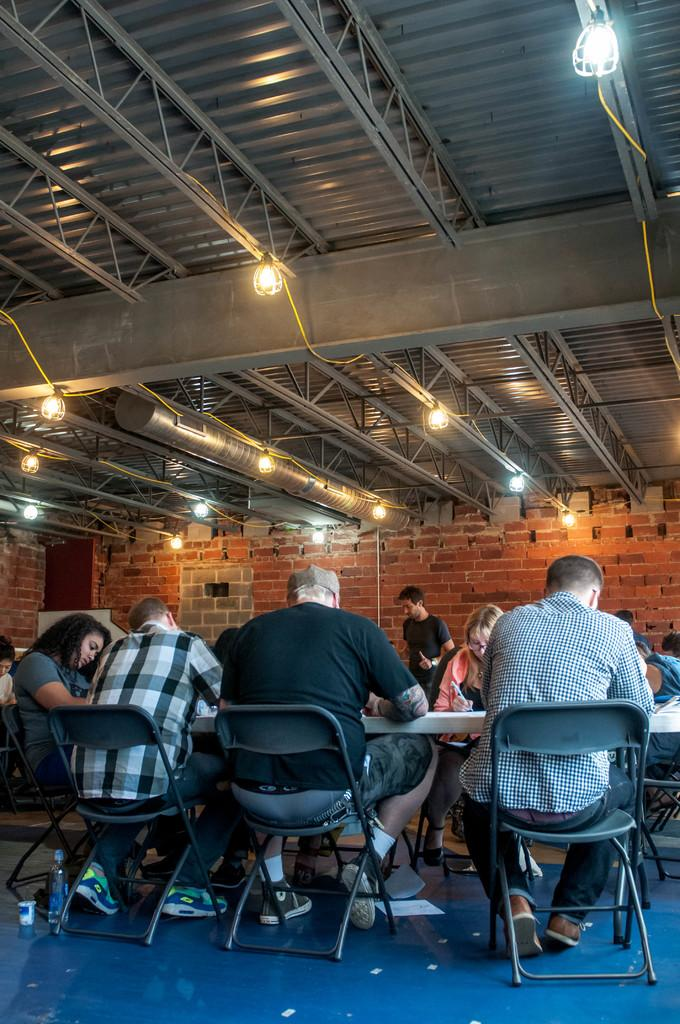What is happening in the image? There are people sitting around a table in the image. What can be seen behind the people? There is a brick wall behind the people. What is on the roof in the image? There is an iron railing on the roof in the image. What is attached to the iron railing? There are lights held on the iron railing. Is there a writer sitting at the table in the image? There is no information about the occupation of the people sitting at the table, so we cannot determine if there is a writer present. Can you see any dirt on the brick wall in the image? The image does not provide information about the cleanliness of the brick wall, so we cannot determine if there is any dirt present. 